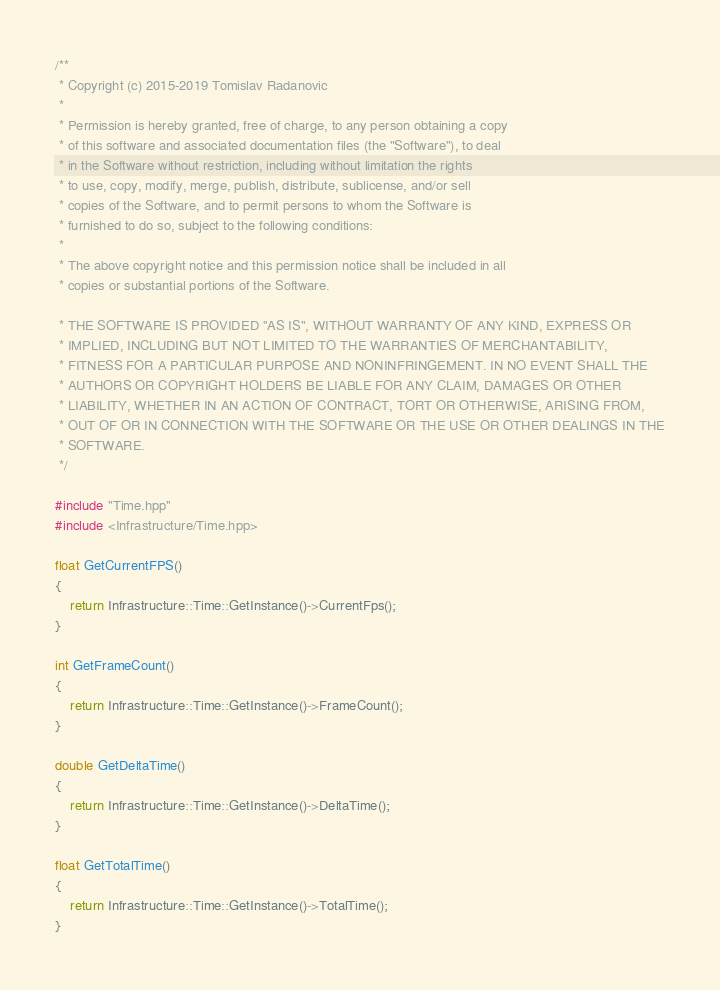<code> <loc_0><loc_0><loc_500><loc_500><_C++_>/**
 * Copyright (c) 2015-2019 Tomislav Radanovic
 *
 * Permission is hereby granted, free of charge, to any person obtaining a copy
 * of this software and associated documentation files (the "Software"), to deal
 * in the Software without restriction, including without limitation the rights
 * to use, copy, modify, merge, publish, distribute, sublicense, and/or sell
 * copies of the Software, and to permit persons to whom the Software is
 * furnished to do so, subject to the following conditions:
 *
 * The above copyright notice and this permission notice shall be included in all
 * copies or substantial portions of the Software.

 * THE SOFTWARE IS PROVIDED "AS IS", WITHOUT WARRANTY OF ANY KIND, EXPRESS OR
 * IMPLIED, INCLUDING BUT NOT LIMITED TO THE WARRANTIES OF MERCHANTABILITY,
 * FITNESS FOR A PARTICULAR PURPOSE AND NONINFRINGEMENT. IN NO EVENT SHALL THE
 * AUTHORS OR COPYRIGHT HOLDERS BE LIABLE FOR ANY CLAIM, DAMAGES OR OTHER
 * LIABILITY, WHETHER IN AN ACTION OF CONTRACT, TORT OR OTHERWISE, ARISING FROM,
 * OUT OF OR IN CONNECTION WITH THE SOFTWARE OR THE USE OR OTHER DEALINGS IN THE
 * SOFTWARE.
 */

#include "Time.hpp"
#include <Infrastructure/Time.hpp>

float GetCurrentFPS()
{
    return Infrastructure::Time::GetInstance()->CurrentFps();
}

int GetFrameCount()
{
    return Infrastructure::Time::GetInstance()->FrameCount();
}

double GetDeltaTime()
{
    return Infrastructure::Time::GetInstance()->DeltaTime();
}

float GetTotalTime()
{
    return Infrastructure::Time::GetInstance()->TotalTime();
}</code> 